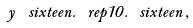Convert formula to latex. <formula><loc_0><loc_0><loc_500><loc_500>y \, \ s i x t e e n . \ r e p { 1 0 } . \ s i x t e e n \, ,</formula> 